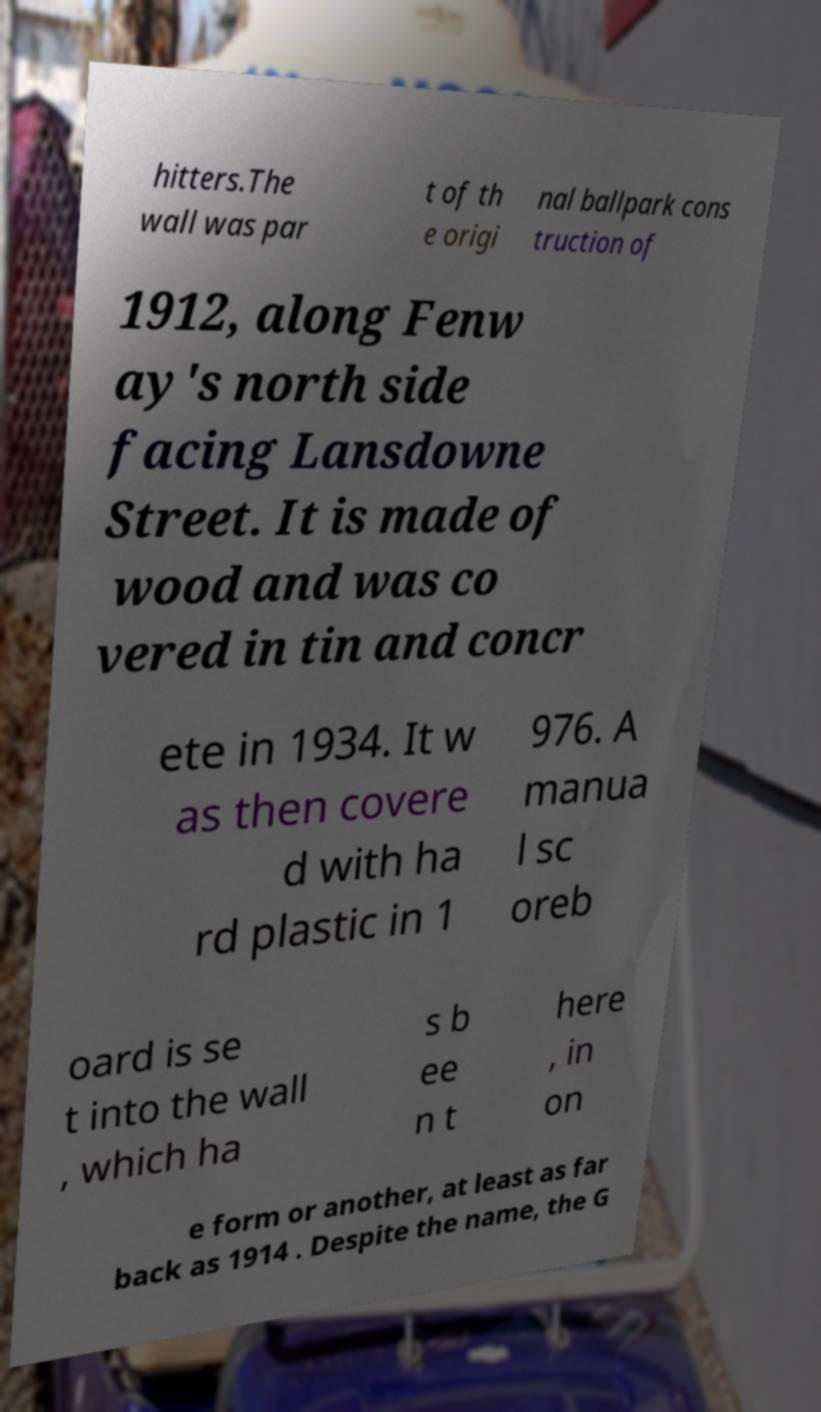There's text embedded in this image that I need extracted. Can you transcribe it verbatim? hitters.The wall was par t of th e origi nal ballpark cons truction of 1912, along Fenw ay's north side facing Lansdowne Street. It is made of wood and was co vered in tin and concr ete in 1934. It w as then covere d with ha rd plastic in 1 976. A manua l sc oreb oard is se t into the wall , which ha s b ee n t here , in on e form or another, at least as far back as 1914 . Despite the name, the G 